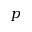<formula> <loc_0><loc_0><loc_500><loc_500>p</formula> 